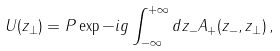Convert formula to latex. <formula><loc_0><loc_0><loc_500><loc_500>U ( z _ { \perp } ) = P \exp - i g \int _ { - \infty } ^ { + \infty } d z _ { - } A _ { + } ( z _ { - } , z _ { \perp } ) \, ,</formula> 